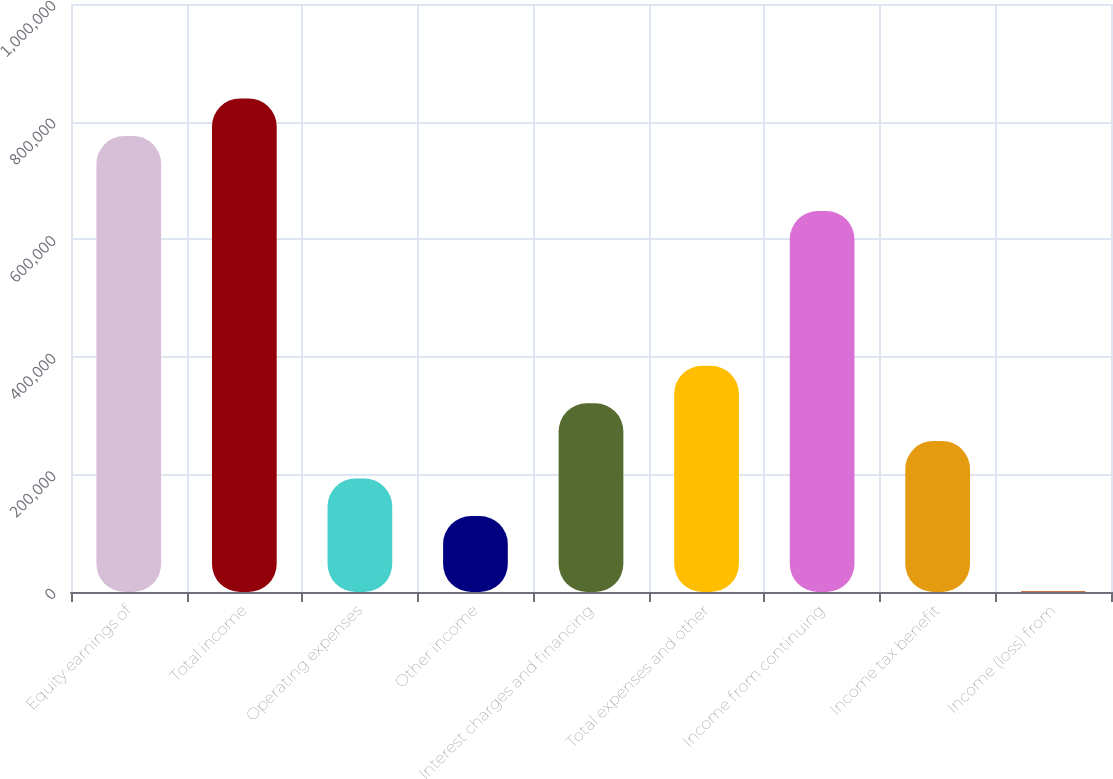Convert chart to OTSL. <chart><loc_0><loc_0><loc_500><loc_500><bar_chart><fcel>Equity earnings of<fcel>Total income<fcel>Operating expenses<fcel>Other income<fcel>Interest charges and financing<fcel>Total expenses and other<fcel>Income from continuing<fcel>Income tax benefit<fcel>Income (loss) from<nl><fcel>775525<fcel>839394<fcel>193056<fcel>129187<fcel>320794<fcel>384664<fcel>647787<fcel>256925<fcel>1449<nl></chart> 